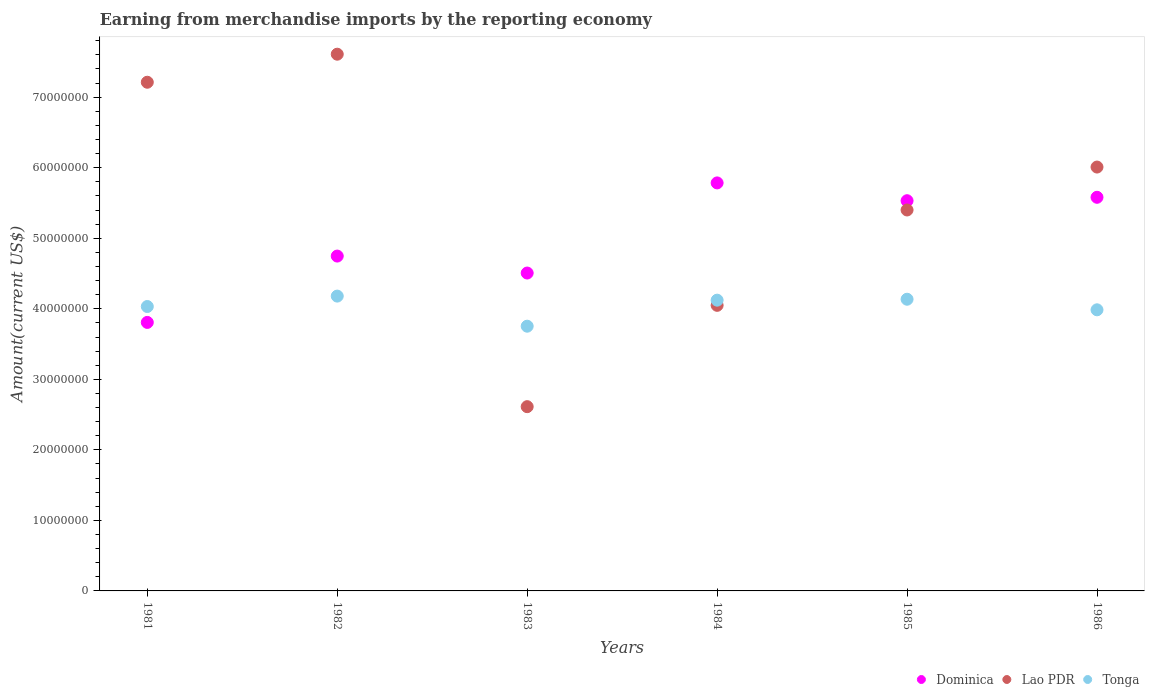What is the amount earned from merchandise imports in Tonga in 1983?
Offer a terse response. 3.75e+07. Across all years, what is the maximum amount earned from merchandise imports in Tonga?
Your answer should be very brief. 4.18e+07. Across all years, what is the minimum amount earned from merchandise imports in Lao PDR?
Your response must be concise. 2.61e+07. In which year was the amount earned from merchandise imports in Dominica maximum?
Ensure brevity in your answer.  1984. In which year was the amount earned from merchandise imports in Lao PDR minimum?
Provide a short and direct response. 1983. What is the total amount earned from merchandise imports in Tonga in the graph?
Your answer should be very brief. 2.42e+08. What is the difference between the amount earned from merchandise imports in Lao PDR in 1981 and that in 1984?
Your response must be concise. 3.16e+07. What is the difference between the amount earned from merchandise imports in Tonga in 1981 and the amount earned from merchandise imports in Lao PDR in 1986?
Give a very brief answer. -1.98e+07. What is the average amount earned from merchandise imports in Dominica per year?
Give a very brief answer. 4.99e+07. In the year 1982, what is the difference between the amount earned from merchandise imports in Tonga and amount earned from merchandise imports in Lao PDR?
Give a very brief answer. -3.43e+07. What is the ratio of the amount earned from merchandise imports in Dominica in 1982 to that in 1986?
Provide a short and direct response. 0.85. What is the difference between the highest and the second highest amount earned from merchandise imports in Lao PDR?
Offer a very short reply. 3.98e+06. What is the difference between the highest and the lowest amount earned from merchandise imports in Dominica?
Your response must be concise. 1.98e+07. Is the amount earned from merchandise imports in Dominica strictly less than the amount earned from merchandise imports in Lao PDR over the years?
Your answer should be very brief. No. How many dotlines are there?
Keep it short and to the point. 3. How many years are there in the graph?
Offer a terse response. 6. What is the difference between two consecutive major ticks on the Y-axis?
Provide a short and direct response. 1.00e+07. Are the values on the major ticks of Y-axis written in scientific E-notation?
Give a very brief answer. No. Does the graph contain any zero values?
Make the answer very short. No. Does the graph contain grids?
Offer a very short reply. No. Where does the legend appear in the graph?
Your answer should be very brief. Bottom right. How many legend labels are there?
Provide a succinct answer. 3. How are the legend labels stacked?
Your response must be concise. Horizontal. What is the title of the graph?
Make the answer very short. Earning from merchandise imports by the reporting economy. What is the label or title of the X-axis?
Make the answer very short. Years. What is the label or title of the Y-axis?
Offer a very short reply. Amount(current US$). What is the Amount(current US$) of Dominica in 1981?
Provide a succinct answer. 3.81e+07. What is the Amount(current US$) of Lao PDR in 1981?
Provide a short and direct response. 7.21e+07. What is the Amount(current US$) in Tonga in 1981?
Offer a very short reply. 4.03e+07. What is the Amount(current US$) of Dominica in 1982?
Give a very brief answer. 4.75e+07. What is the Amount(current US$) of Lao PDR in 1982?
Offer a terse response. 7.61e+07. What is the Amount(current US$) in Tonga in 1982?
Your response must be concise. 4.18e+07. What is the Amount(current US$) in Dominica in 1983?
Keep it short and to the point. 4.51e+07. What is the Amount(current US$) of Lao PDR in 1983?
Make the answer very short. 2.61e+07. What is the Amount(current US$) in Tonga in 1983?
Offer a terse response. 3.75e+07. What is the Amount(current US$) of Dominica in 1984?
Your answer should be compact. 5.78e+07. What is the Amount(current US$) of Lao PDR in 1984?
Make the answer very short. 4.05e+07. What is the Amount(current US$) in Tonga in 1984?
Ensure brevity in your answer.  4.12e+07. What is the Amount(current US$) in Dominica in 1985?
Your answer should be compact. 5.53e+07. What is the Amount(current US$) of Lao PDR in 1985?
Offer a very short reply. 5.40e+07. What is the Amount(current US$) in Tonga in 1985?
Give a very brief answer. 4.14e+07. What is the Amount(current US$) of Dominica in 1986?
Offer a very short reply. 5.58e+07. What is the Amount(current US$) of Lao PDR in 1986?
Give a very brief answer. 6.01e+07. What is the Amount(current US$) of Tonga in 1986?
Make the answer very short. 3.99e+07. Across all years, what is the maximum Amount(current US$) in Dominica?
Make the answer very short. 5.78e+07. Across all years, what is the maximum Amount(current US$) in Lao PDR?
Give a very brief answer. 7.61e+07. Across all years, what is the maximum Amount(current US$) in Tonga?
Provide a short and direct response. 4.18e+07. Across all years, what is the minimum Amount(current US$) of Dominica?
Your answer should be compact. 3.81e+07. Across all years, what is the minimum Amount(current US$) of Lao PDR?
Ensure brevity in your answer.  2.61e+07. Across all years, what is the minimum Amount(current US$) in Tonga?
Offer a very short reply. 3.75e+07. What is the total Amount(current US$) in Dominica in the graph?
Offer a very short reply. 3.00e+08. What is the total Amount(current US$) of Lao PDR in the graph?
Offer a very short reply. 3.29e+08. What is the total Amount(current US$) in Tonga in the graph?
Offer a terse response. 2.42e+08. What is the difference between the Amount(current US$) of Dominica in 1981 and that in 1982?
Make the answer very short. -9.41e+06. What is the difference between the Amount(current US$) in Lao PDR in 1981 and that in 1982?
Give a very brief answer. -3.98e+06. What is the difference between the Amount(current US$) in Tonga in 1981 and that in 1982?
Keep it short and to the point. -1.48e+06. What is the difference between the Amount(current US$) of Dominica in 1981 and that in 1983?
Offer a terse response. -7.00e+06. What is the difference between the Amount(current US$) in Lao PDR in 1981 and that in 1983?
Provide a short and direct response. 4.60e+07. What is the difference between the Amount(current US$) in Tonga in 1981 and that in 1983?
Ensure brevity in your answer.  2.79e+06. What is the difference between the Amount(current US$) in Dominica in 1981 and that in 1984?
Ensure brevity in your answer.  -1.98e+07. What is the difference between the Amount(current US$) in Lao PDR in 1981 and that in 1984?
Ensure brevity in your answer.  3.16e+07. What is the difference between the Amount(current US$) of Tonga in 1981 and that in 1984?
Offer a terse response. -9.00e+05. What is the difference between the Amount(current US$) of Dominica in 1981 and that in 1985?
Offer a terse response. -1.73e+07. What is the difference between the Amount(current US$) in Lao PDR in 1981 and that in 1985?
Give a very brief answer. 1.81e+07. What is the difference between the Amount(current US$) of Tonga in 1981 and that in 1985?
Your answer should be very brief. -1.03e+06. What is the difference between the Amount(current US$) in Dominica in 1981 and that in 1986?
Your response must be concise. -1.77e+07. What is the difference between the Amount(current US$) of Lao PDR in 1981 and that in 1986?
Provide a short and direct response. 1.20e+07. What is the difference between the Amount(current US$) in Tonga in 1981 and that in 1986?
Provide a short and direct response. 4.68e+05. What is the difference between the Amount(current US$) of Dominica in 1982 and that in 1983?
Give a very brief answer. 2.40e+06. What is the difference between the Amount(current US$) in Lao PDR in 1982 and that in 1983?
Offer a terse response. 5.00e+07. What is the difference between the Amount(current US$) of Tonga in 1982 and that in 1983?
Your answer should be compact. 4.27e+06. What is the difference between the Amount(current US$) in Dominica in 1982 and that in 1984?
Give a very brief answer. -1.04e+07. What is the difference between the Amount(current US$) in Lao PDR in 1982 and that in 1984?
Provide a succinct answer. 3.56e+07. What is the difference between the Amount(current US$) in Tonga in 1982 and that in 1984?
Your response must be concise. 5.77e+05. What is the difference between the Amount(current US$) in Dominica in 1982 and that in 1985?
Offer a very short reply. -7.85e+06. What is the difference between the Amount(current US$) in Lao PDR in 1982 and that in 1985?
Provide a short and direct response. 2.21e+07. What is the difference between the Amount(current US$) of Tonga in 1982 and that in 1985?
Keep it short and to the point. 4.45e+05. What is the difference between the Amount(current US$) of Dominica in 1982 and that in 1986?
Provide a short and direct response. -8.33e+06. What is the difference between the Amount(current US$) of Lao PDR in 1982 and that in 1986?
Provide a short and direct response. 1.60e+07. What is the difference between the Amount(current US$) in Tonga in 1982 and that in 1986?
Your response must be concise. 1.94e+06. What is the difference between the Amount(current US$) in Dominica in 1983 and that in 1984?
Your answer should be very brief. -1.28e+07. What is the difference between the Amount(current US$) in Lao PDR in 1983 and that in 1984?
Your answer should be compact. -1.44e+07. What is the difference between the Amount(current US$) in Tonga in 1983 and that in 1984?
Give a very brief answer. -3.69e+06. What is the difference between the Amount(current US$) in Dominica in 1983 and that in 1985?
Your answer should be compact. -1.03e+07. What is the difference between the Amount(current US$) in Lao PDR in 1983 and that in 1985?
Your answer should be compact. -2.79e+07. What is the difference between the Amount(current US$) of Tonga in 1983 and that in 1985?
Offer a very short reply. -3.82e+06. What is the difference between the Amount(current US$) in Dominica in 1983 and that in 1986?
Your answer should be compact. -1.07e+07. What is the difference between the Amount(current US$) in Lao PDR in 1983 and that in 1986?
Ensure brevity in your answer.  -3.40e+07. What is the difference between the Amount(current US$) in Tonga in 1983 and that in 1986?
Make the answer very short. -2.32e+06. What is the difference between the Amount(current US$) in Dominica in 1984 and that in 1985?
Keep it short and to the point. 2.52e+06. What is the difference between the Amount(current US$) in Lao PDR in 1984 and that in 1985?
Provide a short and direct response. -1.35e+07. What is the difference between the Amount(current US$) in Tonga in 1984 and that in 1985?
Ensure brevity in your answer.  -1.32e+05. What is the difference between the Amount(current US$) in Dominica in 1984 and that in 1986?
Keep it short and to the point. 2.04e+06. What is the difference between the Amount(current US$) in Lao PDR in 1984 and that in 1986?
Offer a very short reply. -1.96e+07. What is the difference between the Amount(current US$) of Tonga in 1984 and that in 1986?
Provide a succinct answer. 1.37e+06. What is the difference between the Amount(current US$) of Dominica in 1985 and that in 1986?
Make the answer very short. -4.85e+05. What is the difference between the Amount(current US$) of Lao PDR in 1985 and that in 1986?
Give a very brief answer. -6.09e+06. What is the difference between the Amount(current US$) of Tonga in 1985 and that in 1986?
Provide a succinct answer. 1.50e+06. What is the difference between the Amount(current US$) of Dominica in 1981 and the Amount(current US$) of Lao PDR in 1982?
Keep it short and to the point. -3.80e+07. What is the difference between the Amount(current US$) of Dominica in 1981 and the Amount(current US$) of Tonga in 1982?
Ensure brevity in your answer.  -3.73e+06. What is the difference between the Amount(current US$) of Lao PDR in 1981 and the Amount(current US$) of Tonga in 1982?
Provide a succinct answer. 3.03e+07. What is the difference between the Amount(current US$) of Dominica in 1981 and the Amount(current US$) of Lao PDR in 1983?
Give a very brief answer. 1.19e+07. What is the difference between the Amount(current US$) in Dominica in 1981 and the Amount(current US$) in Tonga in 1983?
Give a very brief answer. 5.37e+05. What is the difference between the Amount(current US$) in Lao PDR in 1981 and the Amount(current US$) in Tonga in 1983?
Your answer should be very brief. 3.46e+07. What is the difference between the Amount(current US$) of Dominica in 1981 and the Amount(current US$) of Lao PDR in 1984?
Make the answer very short. -2.42e+06. What is the difference between the Amount(current US$) in Dominica in 1981 and the Amount(current US$) in Tonga in 1984?
Your answer should be compact. -3.15e+06. What is the difference between the Amount(current US$) of Lao PDR in 1981 and the Amount(current US$) of Tonga in 1984?
Provide a short and direct response. 3.09e+07. What is the difference between the Amount(current US$) in Dominica in 1981 and the Amount(current US$) in Lao PDR in 1985?
Ensure brevity in your answer.  -1.59e+07. What is the difference between the Amount(current US$) of Dominica in 1981 and the Amount(current US$) of Tonga in 1985?
Make the answer very short. -3.29e+06. What is the difference between the Amount(current US$) of Lao PDR in 1981 and the Amount(current US$) of Tonga in 1985?
Provide a short and direct response. 3.08e+07. What is the difference between the Amount(current US$) of Dominica in 1981 and the Amount(current US$) of Lao PDR in 1986?
Provide a short and direct response. -2.20e+07. What is the difference between the Amount(current US$) of Dominica in 1981 and the Amount(current US$) of Tonga in 1986?
Your response must be concise. -1.79e+06. What is the difference between the Amount(current US$) of Lao PDR in 1981 and the Amount(current US$) of Tonga in 1986?
Offer a terse response. 3.23e+07. What is the difference between the Amount(current US$) in Dominica in 1982 and the Amount(current US$) in Lao PDR in 1983?
Provide a short and direct response. 2.14e+07. What is the difference between the Amount(current US$) of Dominica in 1982 and the Amount(current US$) of Tonga in 1983?
Provide a short and direct response. 9.94e+06. What is the difference between the Amount(current US$) in Lao PDR in 1982 and the Amount(current US$) in Tonga in 1983?
Provide a short and direct response. 3.86e+07. What is the difference between the Amount(current US$) of Dominica in 1982 and the Amount(current US$) of Lao PDR in 1984?
Your response must be concise. 6.99e+06. What is the difference between the Amount(current US$) of Dominica in 1982 and the Amount(current US$) of Tonga in 1984?
Keep it short and to the point. 6.25e+06. What is the difference between the Amount(current US$) in Lao PDR in 1982 and the Amount(current US$) in Tonga in 1984?
Offer a terse response. 3.49e+07. What is the difference between the Amount(current US$) of Dominica in 1982 and the Amount(current US$) of Lao PDR in 1985?
Keep it short and to the point. -6.54e+06. What is the difference between the Amount(current US$) in Dominica in 1982 and the Amount(current US$) in Tonga in 1985?
Your answer should be very brief. 6.12e+06. What is the difference between the Amount(current US$) in Lao PDR in 1982 and the Amount(current US$) in Tonga in 1985?
Your response must be concise. 3.47e+07. What is the difference between the Amount(current US$) of Dominica in 1982 and the Amount(current US$) of Lao PDR in 1986?
Provide a succinct answer. -1.26e+07. What is the difference between the Amount(current US$) in Dominica in 1982 and the Amount(current US$) in Tonga in 1986?
Offer a terse response. 7.62e+06. What is the difference between the Amount(current US$) of Lao PDR in 1982 and the Amount(current US$) of Tonga in 1986?
Make the answer very short. 3.62e+07. What is the difference between the Amount(current US$) in Dominica in 1983 and the Amount(current US$) in Lao PDR in 1984?
Provide a short and direct response. 4.58e+06. What is the difference between the Amount(current US$) in Dominica in 1983 and the Amount(current US$) in Tonga in 1984?
Keep it short and to the point. 3.85e+06. What is the difference between the Amount(current US$) of Lao PDR in 1983 and the Amount(current US$) of Tonga in 1984?
Provide a short and direct response. -1.51e+07. What is the difference between the Amount(current US$) of Dominica in 1983 and the Amount(current US$) of Lao PDR in 1985?
Your answer should be very brief. -8.94e+06. What is the difference between the Amount(current US$) of Dominica in 1983 and the Amount(current US$) of Tonga in 1985?
Provide a short and direct response. 3.72e+06. What is the difference between the Amount(current US$) in Lao PDR in 1983 and the Amount(current US$) in Tonga in 1985?
Provide a short and direct response. -1.52e+07. What is the difference between the Amount(current US$) of Dominica in 1983 and the Amount(current US$) of Lao PDR in 1986?
Provide a succinct answer. -1.50e+07. What is the difference between the Amount(current US$) of Dominica in 1983 and the Amount(current US$) of Tonga in 1986?
Provide a succinct answer. 5.22e+06. What is the difference between the Amount(current US$) in Lao PDR in 1983 and the Amount(current US$) in Tonga in 1986?
Provide a succinct answer. -1.37e+07. What is the difference between the Amount(current US$) in Dominica in 1984 and the Amount(current US$) in Lao PDR in 1985?
Your response must be concise. 3.84e+06. What is the difference between the Amount(current US$) of Dominica in 1984 and the Amount(current US$) of Tonga in 1985?
Provide a succinct answer. 1.65e+07. What is the difference between the Amount(current US$) of Lao PDR in 1984 and the Amount(current US$) of Tonga in 1985?
Offer a very short reply. -8.65e+05. What is the difference between the Amount(current US$) in Dominica in 1984 and the Amount(current US$) in Lao PDR in 1986?
Provide a succinct answer. -2.25e+06. What is the difference between the Amount(current US$) of Dominica in 1984 and the Amount(current US$) of Tonga in 1986?
Provide a short and direct response. 1.80e+07. What is the difference between the Amount(current US$) in Lao PDR in 1984 and the Amount(current US$) in Tonga in 1986?
Your answer should be compact. 6.35e+05. What is the difference between the Amount(current US$) in Dominica in 1985 and the Amount(current US$) in Lao PDR in 1986?
Your response must be concise. -4.77e+06. What is the difference between the Amount(current US$) of Dominica in 1985 and the Amount(current US$) of Tonga in 1986?
Offer a terse response. 1.55e+07. What is the difference between the Amount(current US$) of Lao PDR in 1985 and the Amount(current US$) of Tonga in 1986?
Your answer should be very brief. 1.42e+07. What is the average Amount(current US$) in Dominica per year?
Ensure brevity in your answer.  4.99e+07. What is the average Amount(current US$) in Lao PDR per year?
Offer a very short reply. 5.48e+07. What is the average Amount(current US$) in Tonga per year?
Your answer should be very brief. 4.03e+07. In the year 1981, what is the difference between the Amount(current US$) of Dominica and Amount(current US$) of Lao PDR?
Provide a succinct answer. -3.41e+07. In the year 1981, what is the difference between the Amount(current US$) in Dominica and Amount(current US$) in Tonga?
Offer a terse response. -2.25e+06. In the year 1981, what is the difference between the Amount(current US$) in Lao PDR and Amount(current US$) in Tonga?
Your answer should be very brief. 3.18e+07. In the year 1982, what is the difference between the Amount(current US$) of Dominica and Amount(current US$) of Lao PDR?
Provide a short and direct response. -2.86e+07. In the year 1982, what is the difference between the Amount(current US$) of Dominica and Amount(current US$) of Tonga?
Your answer should be very brief. 5.68e+06. In the year 1982, what is the difference between the Amount(current US$) in Lao PDR and Amount(current US$) in Tonga?
Offer a very short reply. 3.43e+07. In the year 1983, what is the difference between the Amount(current US$) of Dominica and Amount(current US$) of Lao PDR?
Provide a short and direct response. 1.89e+07. In the year 1983, what is the difference between the Amount(current US$) of Dominica and Amount(current US$) of Tonga?
Offer a terse response. 7.54e+06. In the year 1983, what is the difference between the Amount(current US$) of Lao PDR and Amount(current US$) of Tonga?
Provide a succinct answer. -1.14e+07. In the year 1984, what is the difference between the Amount(current US$) of Dominica and Amount(current US$) of Lao PDR?
Make the answer very short. 1.74e+07. In the year 1984, what is the difference between the Amount(current US$) of Dominica and Amount(current US$) of Tonga?
Your answer should be very brief. 1.66e+07. In the year 1984, what is the difference between the Amount(current US$) in Lao PDR and Amount(current US$) in Tonga?
Make the answer very short. -7.33e+05. In the year 1985, what is the difference between the Amount(current US$) of Dominica and Amount(current US$) of Lao PDR?
Your answer should be compact. 1.31e+06. In the year 1985, what is the difference between the Amount(current US$) of Dominica and Amount(current US$) of Tonga?
Your answer should be very brief. 1.40e+07. In the year 1985, what is the difference between the Amount(current US$) of Lao PDR and Amount(current US$) of Tonga?
Provide a short and direct response. 1.27e+07. In the year 1986, what is the difference between the Amount(current US$) of Dominica and Amount(current US$) of Lao PDR?
Your answer should be very brief. -4.29e+06. In the year 1986, what is the difference between the Amount(current US$) in Dominica and Amount(current US$) in Tonga?
Your answer should be very brief. 1.60e+07. In the year 1986, what is the difference between the Amount(current US$) in Lao PDR and Amount(current US$) in Tonga?
Make the answer very short. 2.02e+07. What is the ratio of the Amount(current US$) in Dominica in 1981 to that in 1982?
Offer a terse response. 0.8. What is the ratio of the Amount(current US$) of Lao PDR in 1981 to that in 1982?
Offer a very short reply. 0.95. What is the ratio of the Amount(current US$) of Tonga in 1981 to that in 1982?
Provide a short and direct response. 0.96. What is the ratio of the Amount(current US$) in Dominica in 1981 to that in 1983?
Provide a succinct answer. 0.84. What is the ratio of the Amount(current US$) of Lao PDR in 1981 to that in 1983?
Offer a very short reply. 2.76. What is the ratio of the Amount(current US$) in Tonga in 1981 to that in 1983?
Give a very brief answer. 1.07. What is the ratio of the Amount(current US$) of Dominica in 1981 to that in 1984?
Offer a very short reply. 0.66. What is the ratio of the Amount(current US$) in Lao PDR in 1981 to that in 1984?
Offer a very short reply. 1.78. What is the ratio of the Amount(current US$) of Tonga in 1981 to that in 1984?
Your answer should be compact. 0.98. What is the ratio of the Amount(current US$) of Dominica in 1981 to that in 1985?
Give a very brief answer. 0.69. What is the ratio of the Amount(current US$) of Lao PDR in 1981 to that in 1985?
Give a very brief answer. 1.34. What is the ratio of the Amount(current US$) in Dominica in 1981 to that in 1986?
Ensure brevity in your answer.  0.68. What is the ratio of the Amount(current US$) in Lao PDR in 1981 to that in 1986?
Offer a terse response. 1.2. What is the ratio of the Amount(current US$) in Tonga in 1981 to that in 1986?
Your response must be concise. 1.01. What is the ratio of the Amount(current US$) in Dominica in 1982 to that in 1983?
Ensure brevity in your answer.  1.05. What is the ratio of the Amount(current US$) in Lao PDR in 1982 to that in 1983?
Offer a very short reply. 2.91. What is the ratio of the Amount(current US$) of Tonga in 1982 to that in 1983?
Provide a succinct answer. 1.11. What is the ratio of the Amount(current US$) in Dominica in 1982 to that in 1984?
Offer a very short reply. 0.82. What is the ratio of the Amount(current US$) of Lao PDR in 1982 to that in 1984?
Provide a short and direct response. 1.88. What is the ratio of the Amount(current US$) of Dominica in 1982 to that in 1985?
Your response must be concise. 0.86. What is the ratio of the Amount(current US$) in Lao PDR in 1982 to that in 1985?
Provide a short and direct response. 1.41. What is the ratio of the Amount(current US$) in Tonga in 1982 to that in 1985?
Offer a very short reply. 1.01. What is the ratio of the Amount(current US$) in Dominica in 1982 to that in 1986?
Keep it short and to the point. 0.85. What is the ratio of the Amount(current US$) of Lao PDR in 1982 to that in 1986?
Keep it short and to the point. 1.27. What is the ratio of the Amount(current US$) in Tonga in 1982 to that in 1986?
Offer a terse response. 1.05. What is the ratio of the Amount(current US$) of Dominica in 1983 to that in 1984?
Provide a succinct answer. 0.78. What is the ratio of the Amount(current US$) in Lao PDR in 1983 to that in 1984?
Make the answer very short. 0.65. What is the ratio of the Amount(current US$) of Tonga in 1983 to that in 1984?
Keep it short and to the point. 0.91. What is the ratio of the Amount(current US$) in Dominica in 1983 to that in 1985?
Ensure brevity in your answer.  0.81. What is the ratio of the Amount(current US$) of Lao PDR in 1983 to that in 1985?
Provide a short and direct response. 0.48. What is the ratio of the Amount(current US$) of Tonga in 1983 to that in 1985?
Your answer should be very brief. 0.91. What is the ratio of the Amount(current US$) of Dominica in 1983 to that in 1986?
Your answer should be compact. 0.81. What is the ratio of the Amount(current US$) in Lao PDR in 1983 to that in 1986?
Provide a short and direct response. 0.43. What is the ratio of the Amount(current US$) of Tonga in 1983 to that in 1986?
Give a very brief answer. 0.94. What is the ratio of the Amount(current US$) of Dominica in 1984 to that in 1985?
Make the answer very short. 1.05. What is the ratio of the Amount(current US$) in Lao PDR in 1984 to that in 1985?
Make the answer very short. 0.75. What is the ratio of the Amount(current US$) in Tonga in 1984 to that in 1985?
Make the answer very short. 1. What is the ratio of the Amount(current US$) in Dominica in 1984 to that in 1986?
Offer a very short reply. 1.04. What is the ratio of the Amount(current US$) of Lao PDR in 1984 to that in 1986?
Give a very brief answer. 0.67. What is the ratio of the Amount(current US$) in Tonga in 1984 to that in 1986?
Your response must be concise. 1.03. What is the ratio of the Amount(current US$) of Dominica in 1985 to that in 1986?
Provide a succinct answer. 0.99. What is the ratio of the Amount(current US$) in Lao PDR in 1985 to that in 1986?
Ensure brevity in your answer.  0.9. What is the ratio of the Amount(current US$) in Tonga in 1985 to that in 1986?
Make the answer very short. 1.04. What is the difference between the highest and the second highest Amount(current US$) of Dominica?
Offer a terse response. 2.04e+06. What is the difference between the highest and the second highest Amount(current US$) of Lao PDR?
Provide a succinct answer. 3.98e+06. What is the difference between the highest and the second highest Amount(current US$) of Tonga?
Your answer should be compact. 4.45e+05. What is the difference between the highest and the lowest Amount(current US$) in Dominica?
Make the answer very short. 1.98e+07. What is the difference between the highest and the lowest Amount(current US$) in Lao PDR?
Your response must be concise. 5.00e+07. What is the difference between the highest and the lowest Amount(current US$) of Tonga?
Make the answer very short. 4.27e+06. 